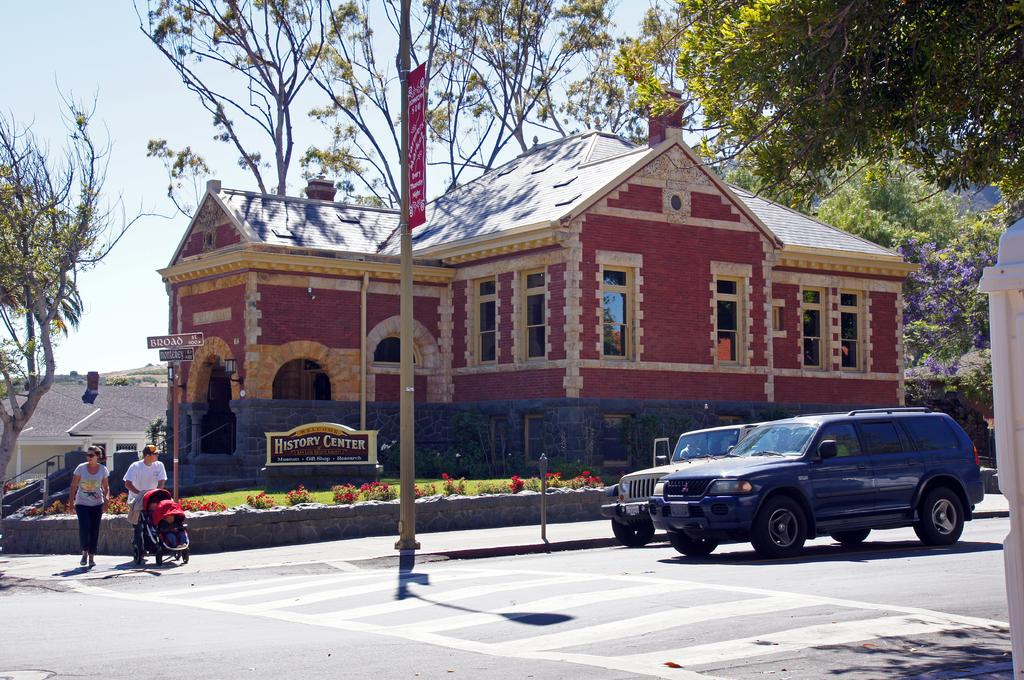What type of structure is visible in the image? There is a house in the image. What color is the house? The house is painted red. What can be seen in the background of the image? There are many trees in the image. What are the people in the image doing? Two people are walking on the road. What vehicles are moving on the road? A jeep and a car are moving on the road. Can you see a fork in the eye of the person walking on the road? There is no fork or person with a fork in their eye visible in the image. 